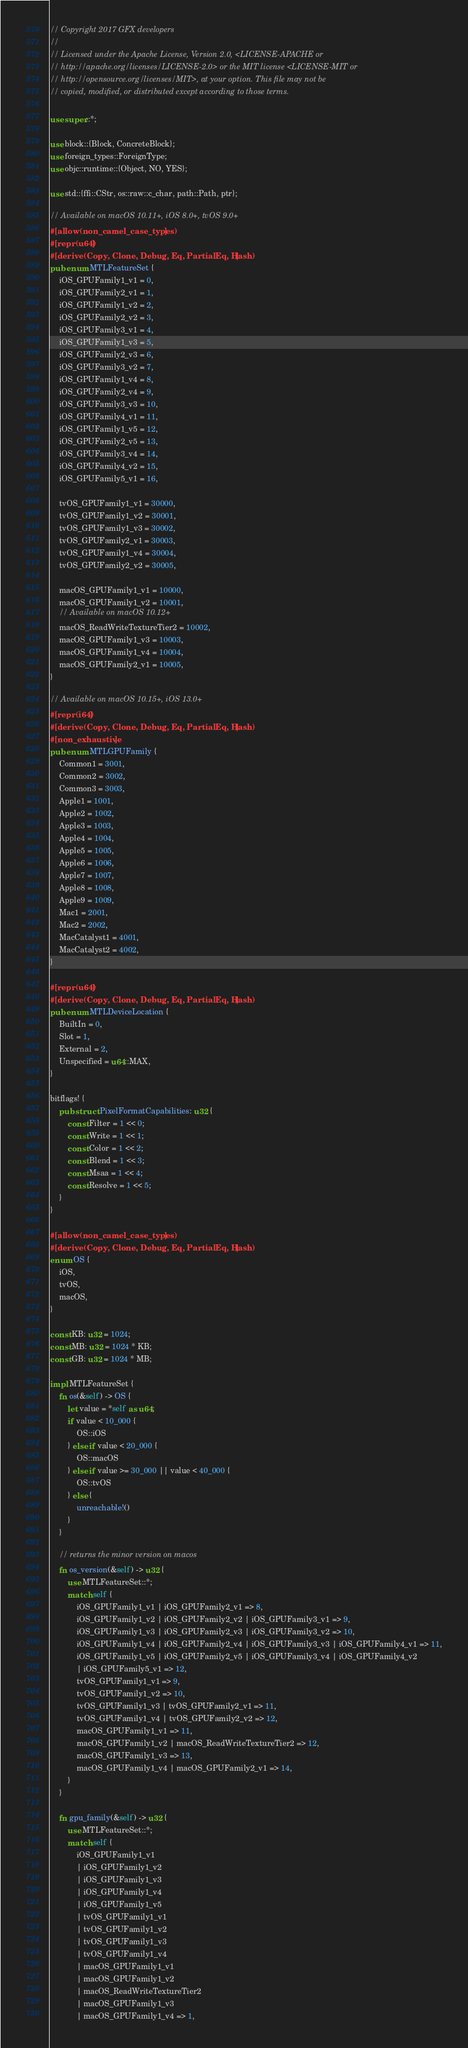<code> <loc_0><loc_0><loc_500><loc_500><_Rust_>// Copyright 2017 GFX developers
//
// Licensed under the Apache License, Version 2.0, <LICENSE-APACHE or
// http://apache.org/licenses/LICENSE-2.0> or the MIT license <LICENSE-MIT or
// http://opensource.org/licenses/MIT>, at your option. This file may not be
// copied, modified, or distributed except according to those terms.

use super::*;

use block::{Block, ConcreteBlock};
use foreign_types::ForeignType;
use objc::runtime::{Object, NO, YES};

use std::{ffi::CStr, os::raw::c_char, path::Path, ptr};

// Available on macOS 10.11+, iOS 8.0+, tvOS 9.0+
#[allow(non_camel_case_types)]
#[repr(u64)]
#[derive(Copy, Clone, Debug, Eq, PartialEq, Hash)]
pub enum MTLFeatureSet {
    iOS_GPUFamily1_v1 = 0,
    iOS_GPUFamily2_v1 = 1,
    iOS_GPUFamily1_v2 = 2,
    iOS_GPUFamily2_v2 = 3,
    iOS_GPUFamily3_v1 = 4,
    iOS_GPUFamily1_v3 = 5,
    iOS_GPUFamily2_v3 = 6,
    iOS_GPUFamily3_v2 = 7,
    iOS_GPUFamily1_v4 = 8,
    iOS_GPUFamily2_v4 = 9,
    iOS_GPUFamily3_v3 = 10,
    iOS_GPUFamily4_v1 = 11,
    iOS_GPUFamily1_v5 = 12,
    iOS_GPUFamily2_v5 = 13,
    iOS_GPUFamily3_v4 = 14,
    iOS_GPUFamily4_v2 = 15,
    iOS_GPUFamily5_v1 = 16,

    tvOS_GPUFamily1_v1 = 30000,
    tvOS_GPUFamily1_v2 = 30001,
    tvOS_GPUFamily1_v3 = 30002,
    tvOS_GPUFamily2_v1 = 30003,
    tvOS_GPUFamily1_v4 = 30004,
    tvOS_GPUFamily2_v2 = 30005,

    macOS_GPUFamily1_v1 = 10000,
    macOS_GPUFamily1_v2 = 10001,
    // Available on macOS 10.12+
    macOS_ReadWriteTextureTier2 = 10002,
    macOS_GPUFamily1_v3 = 10003,
    macOS_GPUFamily1_v4 = 10004,
    macOS_GPUFamily2_v1 = 10005,
}

// Available on macOS 10.15+, iOS 13.0+
#[repr(i64)]
#[derive(Copy, Clone, Debug, Eq, PartialEq, Hash)]
#[non_exhaustive]
pub enum MTLGPUFamily {
    Common1 = 3001,
    Common2 = 3002,
    Common3 = 3003,
    Apple1 = 1001,
    Apple2 = 1002,
    Apple3 = 1003,
    Apple4 = 1004,
    Apple5 = 1005,
    Apple6 = 1006,
    Apple7 = 1007,
    Apple8 = 1008,
    Apple9 = 1009,
    Mac1 = 2001,
    Mac2 = 2002,
    MacCatalyst1 = 4001,
    MacCatalyst2 = 4002,
}

#[repr(u64)]
#[derive(Copy, Clone, Debug, Eq, PartialEq, Hash)]
pub enum MTLDeviceLocation {
    BuiltIn = 0,
    Slot = 1,
    External = 2,
    Unspecified = u64::MAX,
}

bitflags! {
    pub struct PixelFormatCapabilities: u32 {
        const Filter = 1 << 0;
        const Write = 1 << 1;
        const Color = 1 << 2;
        const Blend = 1 << 3;
        const Msaa = 1 << 4;
        const Resolve = 1 << 5;
    }
}

#[allow(non_camel_case_types)]
#[derive(Copy, Clone, Debug, Eq, PartialEq, Hash)]
enum OS {
    iOS,
    tvOS,
    macOS,
}

const KB: u32 = 1024;
const MB: u32 = 1024 * KB;
const GB: u32 = 1024 * MB;

impl MTLFeatureSet {
    fn os(&self) -> OS {
        let value = *self as u64;
        if value < 10_000 {
            OS::iOS
        } else if value < 20_000 {
            OS::macOS
        } else if value >= 30_000 || value < 40_000 {
            OS::tvOS
        } else {
            unreachable!()
        }
    }

    // returns the minor version on macos
    fn os_version(&self) -> u32 {
        use MTLFeatureSet::*;
        match self {
            iOS_GPUFamily1_v1 | iOS_GPUFamily2_v1 => 8,
            iOS_GPUFamily1_v2 | iOS_GPUFamily2_v2 | iOS_GPUFamily3_v1 => 9,
            iOS_GPUFamily1_v3 | iOS_GPUFamily2_v3 | iOS_GPUFamily3_v2 => 10,
            iOS_GPUFamily1_v4 | iOS_GPUFamily2_v4 | iOS_GPUFamily3_v3 | iOS_GPUFamily4_v1 => 11,
            iOS_GPUFamily1_v5 | iOS_GPUFamily2_v5 | iOS_GPUFamily3_v4 | iOS_GPUFamily4_v2
            | iOS_GPUFamily5_v1 => 12,
            tvOS_GPUFamily1_v1 => 9,
            tvOS_GPUFamily1_v2 => 10,
            tvOS_GPUFamily1_v3 | tvOS_GPUFamily2_v1 => 11,
            tvOS_GPUFamily1_v4 | tvOS_GPUFamily2_v2 => 12,
            macOS_GPUFamily1_v1 => 11,
            macOS_GPUFamily1_v2 | macOS_ReadWriteTextureTier2 => 12,
            macOS_GPUFamily1_v3 => 13,
            macOS_GPUFamily1_v4 | macOS_GPUFamily2_v1 => 14,
        }
    }

    fn gpu_family(&self) -> u32 {
        use MTLFeatureSet::*;
        match self {
            iOS_GPUFamily1_v1
            | iOS_GPUFamily1_v2
            | iOS_GPUFamily1_v3
            | iOS_GPUFamily1_v4
            | iOS_GPUFamily1_v5
            | tvOS_GPUFamily1_v1
            | tvOS_GPUFamily1_v2
            | tvOS_GPUFamily1_v3
            | tvOS_GPUFamily1_v4
            | macOS_GPUFamily1_v1
            | macOS_GPUFamily1_v2
            | macOS_ReadWriteTextureTier2
            | macOS_GPUFamily1_v3
            | macOS_GPUFamily1_v4 => 1,</code> 